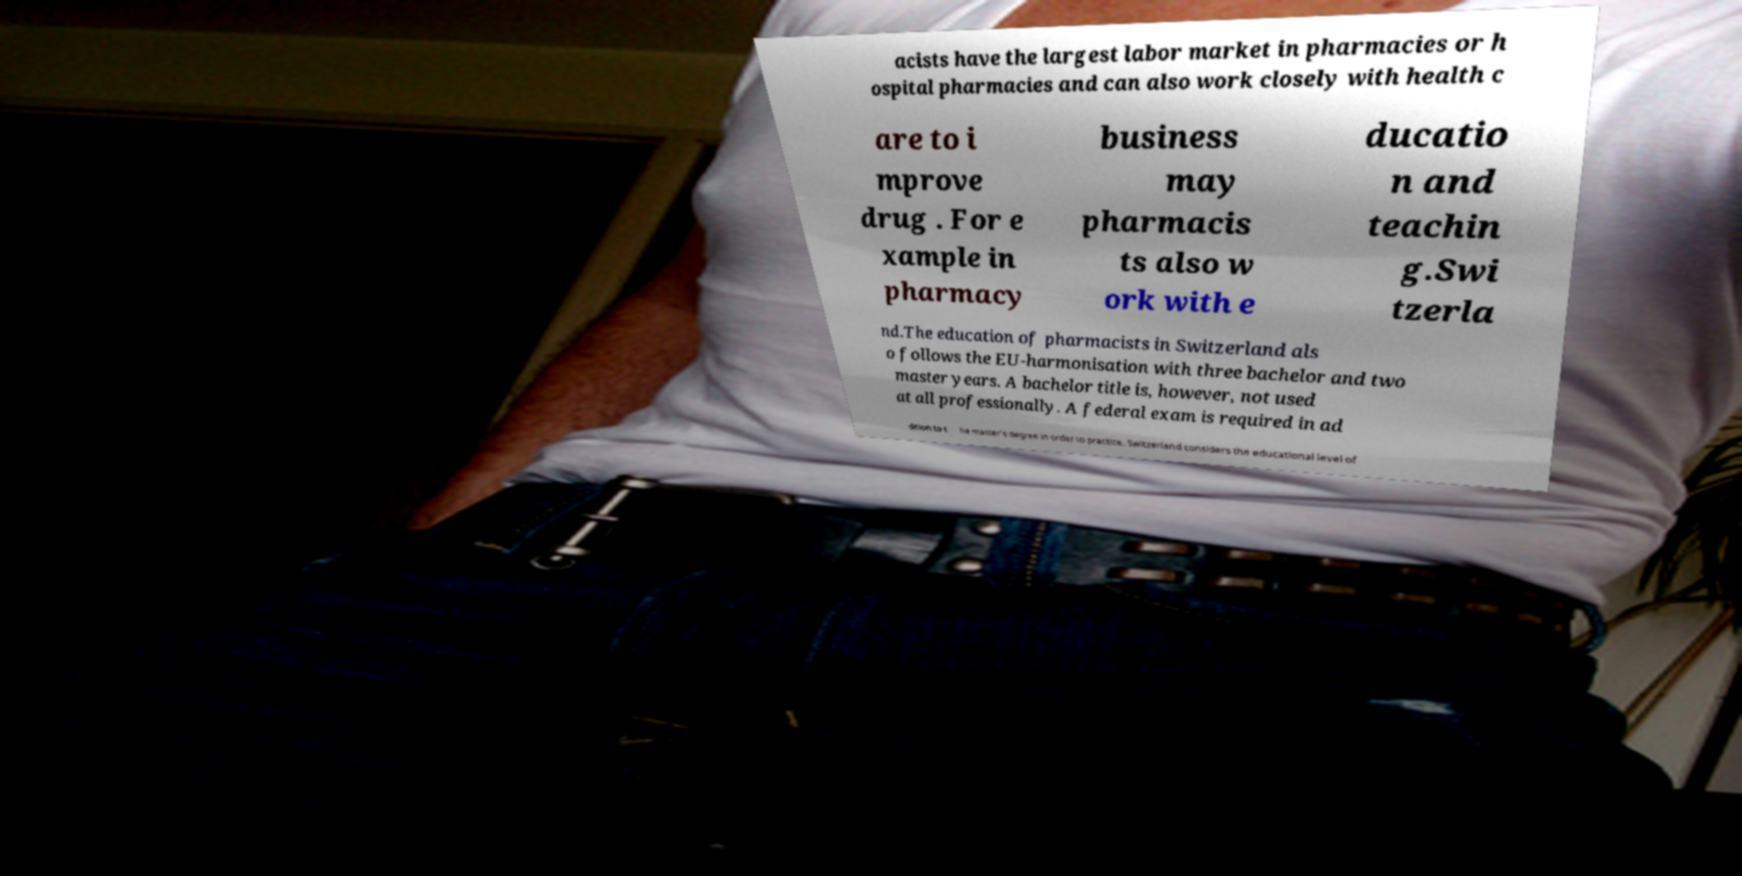For documentation purposes, I need the text within this image transcribed. Could you provide that? acists have the largest labor market in pharmacies or h ospital pharmacies and can also work closely with health c are to i mprove drug . For e xample in pharmacy business may pharmacis ts also w ork with e ducatio n and teachin g.Swi tzerla nd.The education of pharmacists in Switzerland als o follows the EU-harmonisation with three bachelor and two master years. A bachelor title is, however, not used at all professionally. A federal exam is required in ad dition to t he master's degree in order to practice. Switzerland considers the educational level of 